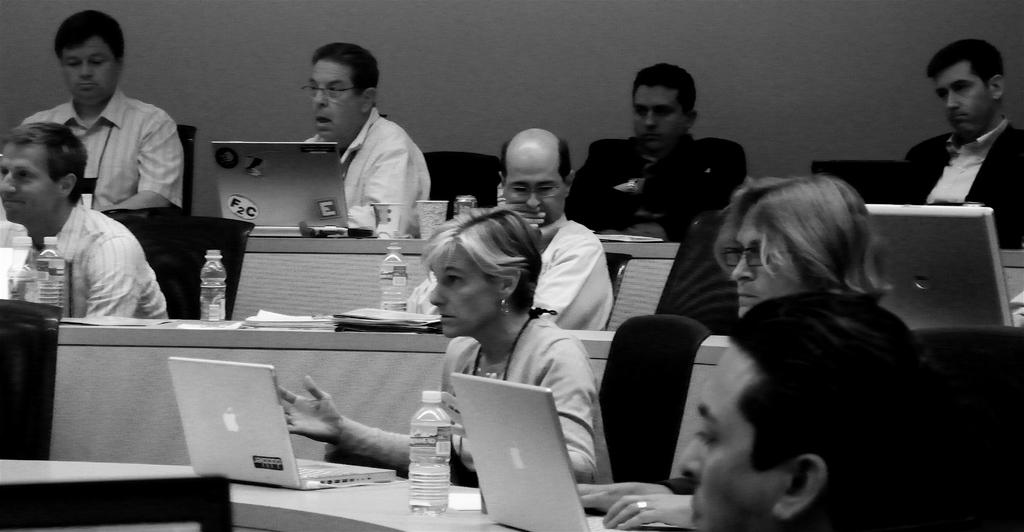What are the people in the image doing? The people in the image are sitting on chairs. What objects can be seen on the table in the image? There are laptops, a water bottle, and papers on the table. What is the color scheme of the image? The image is in black and white color. How many copies of the document can be seen on the table? There is no mention of copies or documents in the image; only papers are mentioned. What type of knot is being used to secure the laptop to the table? There is no knot present in the image; the laptops are simply placed on the table. 